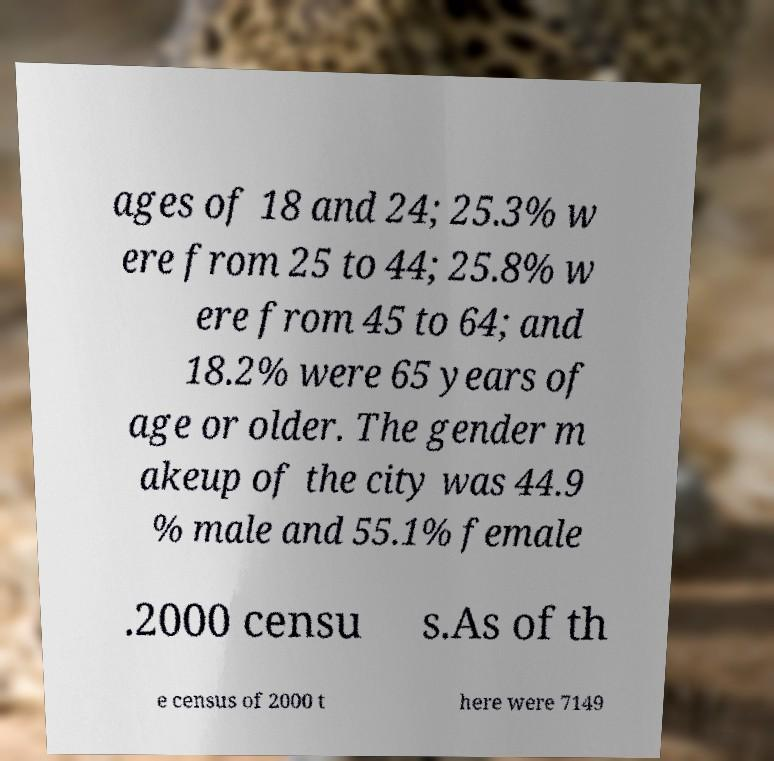What messages or text are displayed in this image? I need them in a readable, typed format. ages of 18 and 24; 25.3% w ere from 25 to 44; 25.8% w ere from 45 to 64; and 18.2% were 65 years of age or older. The gender m akeup of the city was 44.9 % male and 55.1% female .2000 censu s.As of th e census of 2000 t here were 7149 